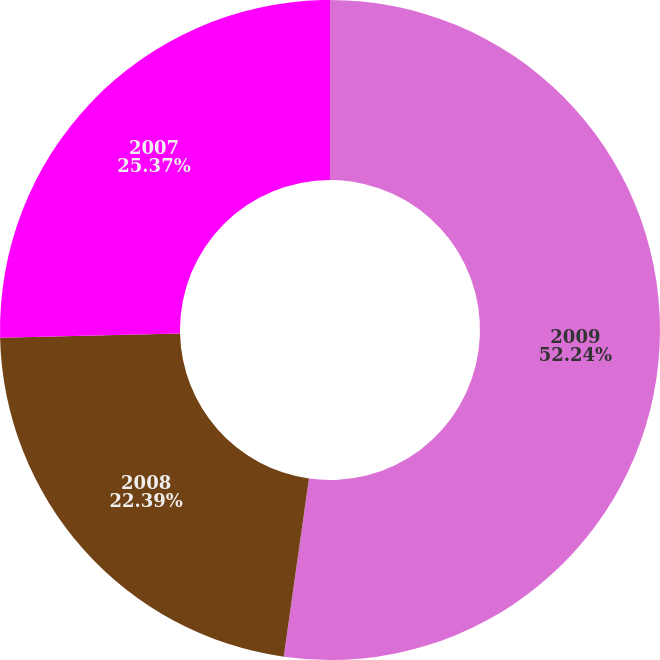Convert chart to OTSL. <chart><loc_0><loc_0><loc_500><loc_500><pie_chart><fcel>2009<fcel>2008<fcel>2007<nl><fcel>52.24%<fcel>22.39%<fcel>25.37%<nl></chart> 